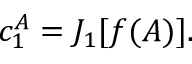Convert formula to latex. <formula><loc_0><loc_0><loc_500><loc_500>c _ { 1 } ^ { A } = J _ { 1 } [ f ( A ) ] .</formula> 